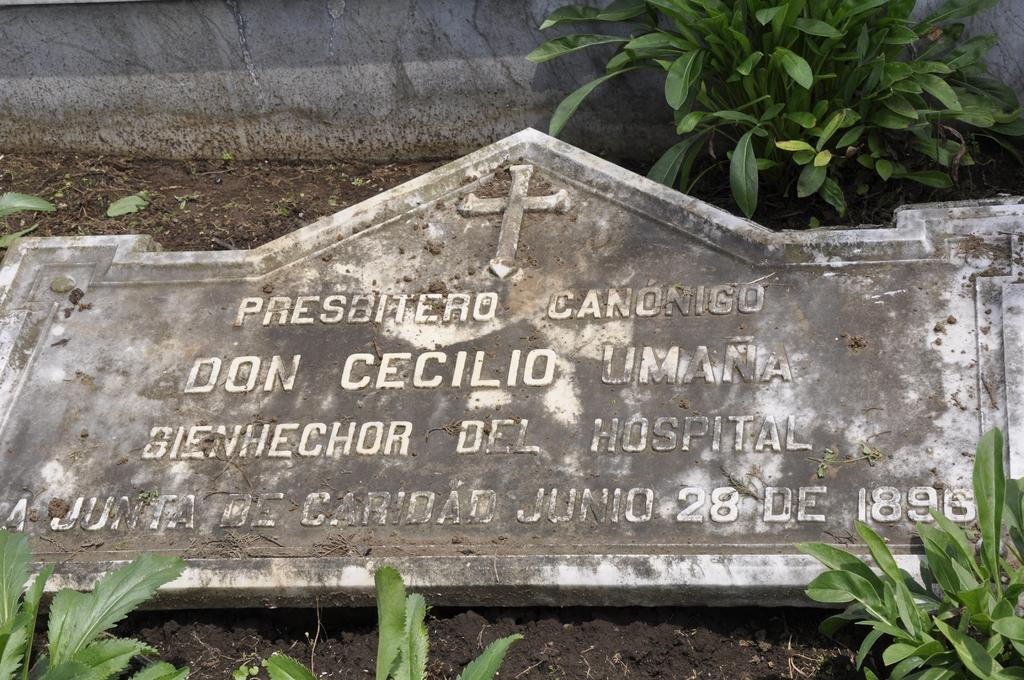What is the main object in the image? There is a large stone in the image. What else can be seen in the image besides the stone? There are plants in the image. What is visible in the background of the image? There is a wall in the background of the image. How many rings can be seen on the creature in the image? There is no creature present in the image, and therefore no rings can be observed. 